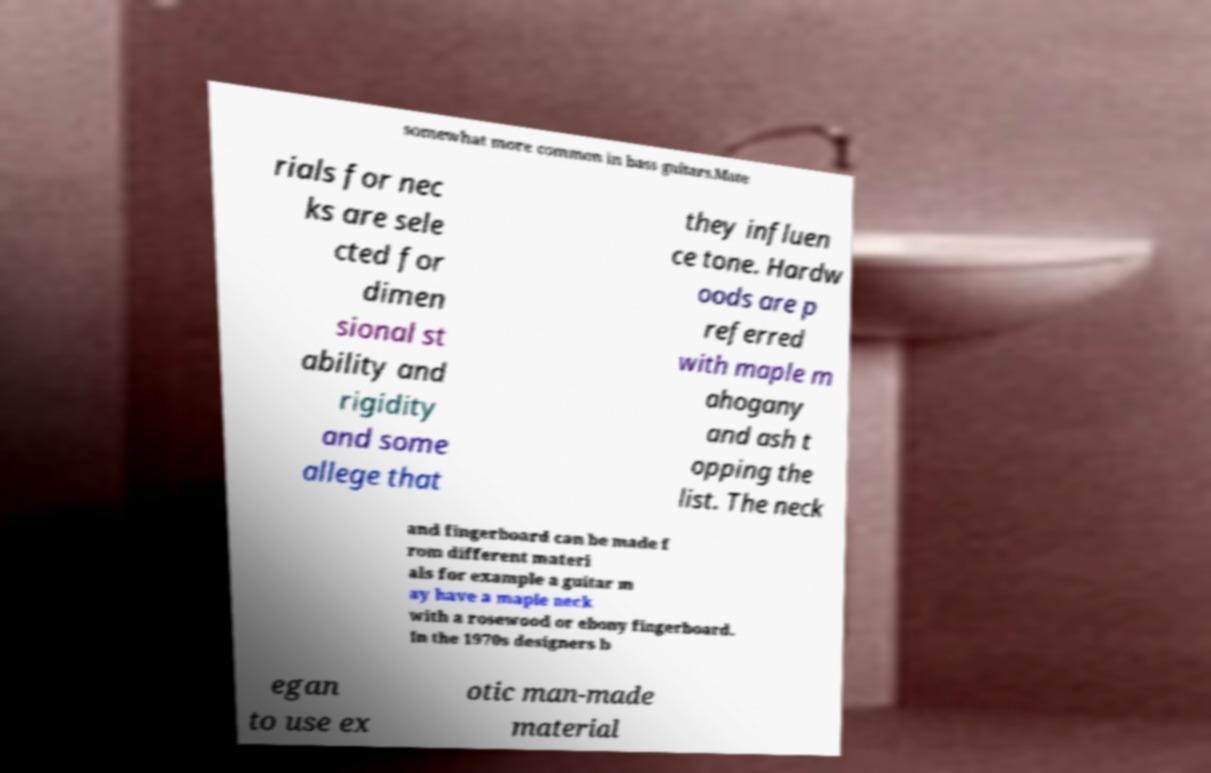What messages or text are displayed in this image? I need them in a readable, typed format. somewhat more common in bass guitars.Mate rials for nec ks are sele cted for dimen sional st ability and rigidity and some allege that they influen ce tone. Hardw oods are p referred with maple m ahogany and ash t opping the list. The neck and fingerboard can be made f rom different materi als for example a guitar m ay have a maple neck with a rosewood or ebony fingerboard. In the 1970s designers b egan to use ex otic man-made material 